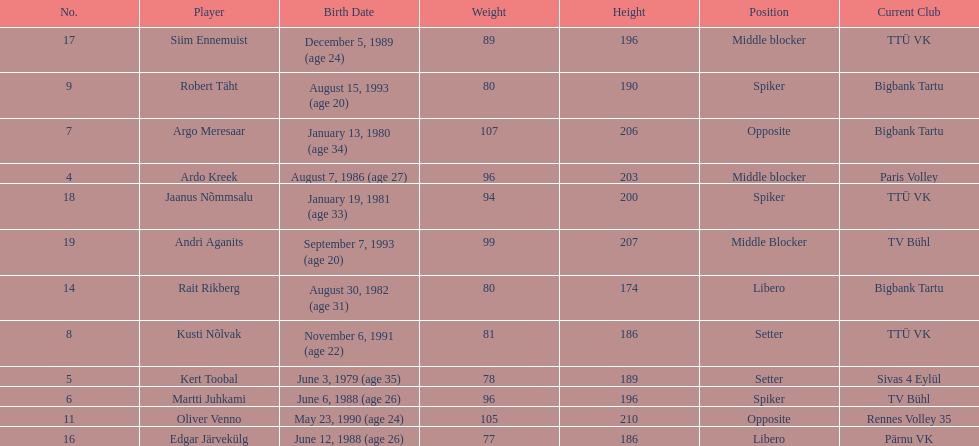How many players are middle blockers? 3. 